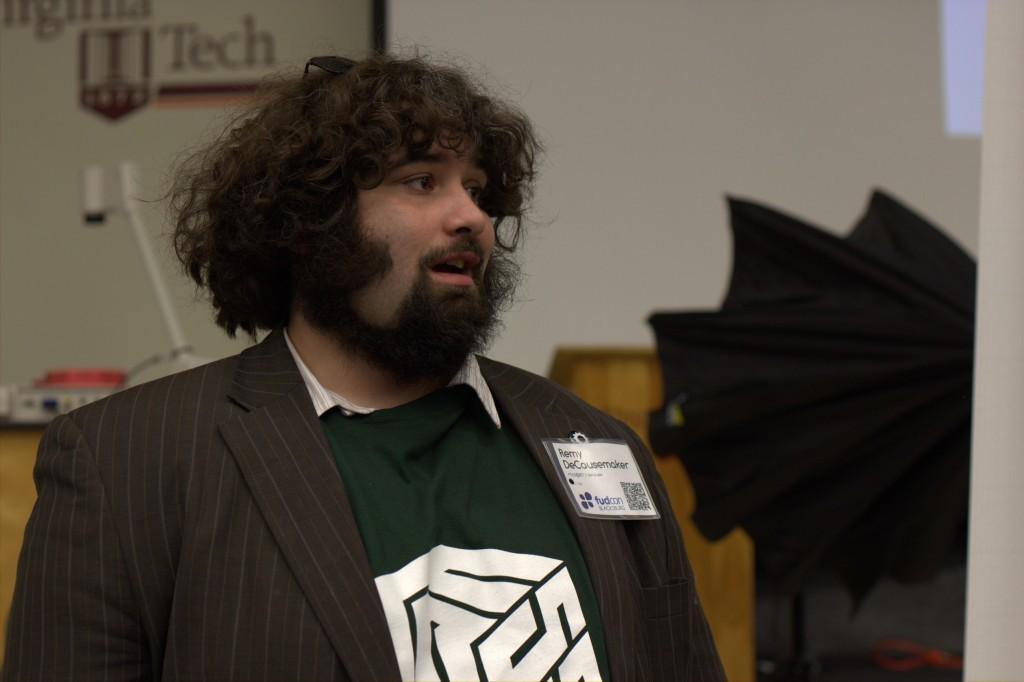Please provide a concise description of this image. In this image we can see a man. On the backside we can see an umbrella, a speaker stand, some objects on a table and a board on a wall with some text on it. 